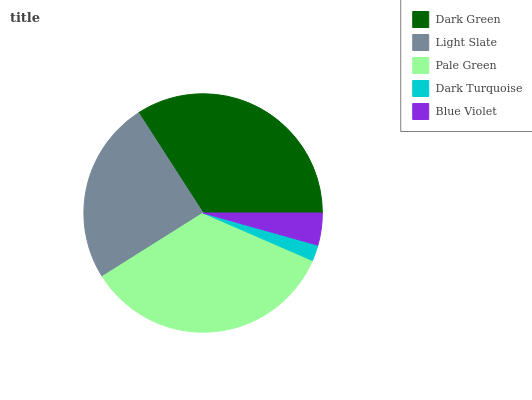Is Dark Turquoise the minimum?
Answer yes or no. Yes. Is Pale Green the maximum?
Answer yes or no. Yes. Is Light Slate the minimum?
Answer yes or no. No. Is Light Slate the maximum?
Answer yes or no. No. Is Dark Green greater than Light Slate?
Answer yes or no. Yes. Is Light Slate less than Dark Green?
Answer yes or no. Yes. Is Light Slate greater than Dark Green?
Answer yes or no. No. Is Dark Green less than Light Slate?
Answer yes or no. No. Is Light Slate the high median?
Answer yes or no. Yes. Is Light Slate the low median?
Answer yes or no. Yes. Is Pale Green the high median?
Answer yes or no. No. Is Pale Green the low median?
Answer yes or no. No. 